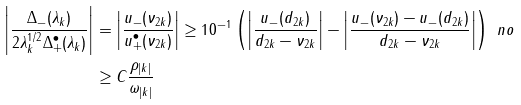<formula> <loc_0><loc_0><loc_500><loc_500>\left | \frac { \Delta _ { - } ( \lambda _ { k } ) } { 2 \lambda _ { k } ^ { 1 / 2 } \Delta _ { + } ^ { \bullet } ( \lambda _ { k } ) } \right | & = \left | \frac { u _ { - } ( \nu _ { 2 k } ) } { u _ { + } ^ { \bullet } ( \nu _ { 2 k } ) } \right | \geq 1 0 ^ { - 1 } \left ( \left | \frac { u _ { - } ( d _ { 2 k } ) } { d _ { 2 k } - \nu _ { 2 k } } \right | - \left | \frac { u _ { - } ( \nu _ { 2 k } ) - u _ { - } ( d _ { 2 k } ) } { d _ { 2 k } - \nu _ { 2 k } } \right | \right ) \ n o \\ & \geq C \frac { \rho _ { | k | } } { \omega _ { | k | } }</formula> 